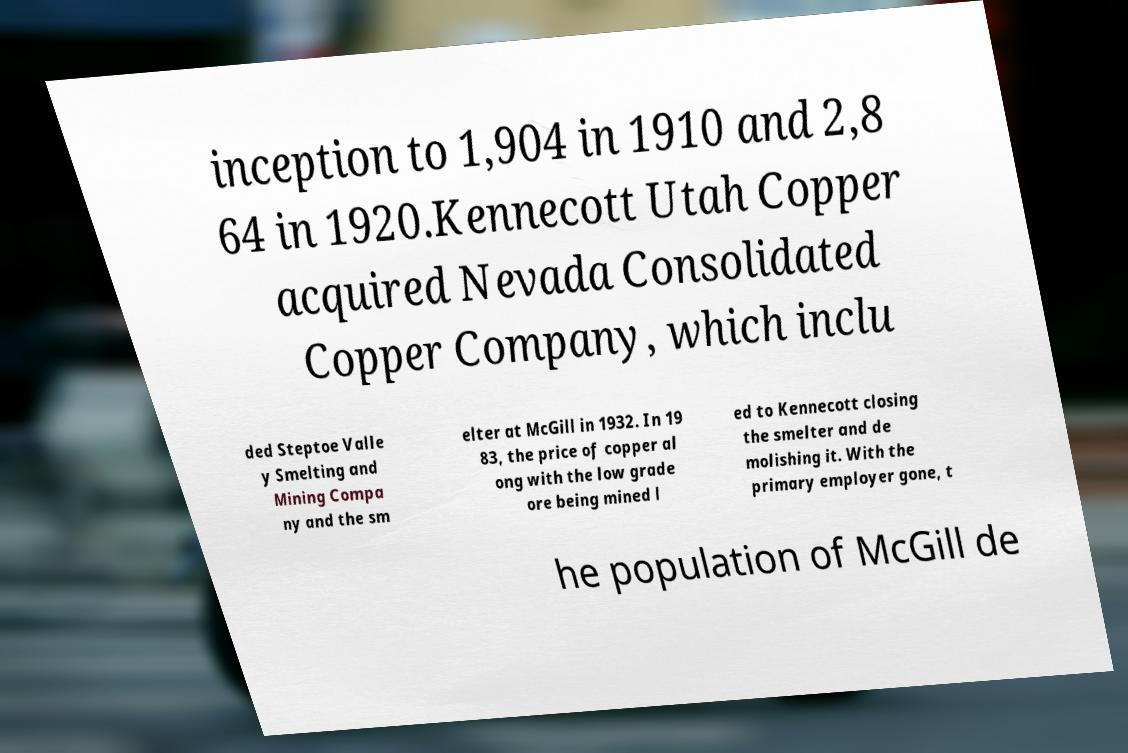What messages or text are displayed in this image? I need them in a readable, typed format. inception to 1,904 in 1910 and 2,8 64 in 1920.Kennecott Utah Copper acquired Nevada Consolidated Copper Company, which inclu ded Steptoe Valle y Smelting and Mining Compa ny and the sm elter at McGill in 1932. In 19 83, the price of copper al ong with the low grade ore being mined l ed to Kennecott closing the smelter and de molishing it. With the primary employer gone, t he population of McGill de 